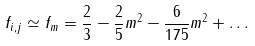Convert formula to latex. <formula><loc_0><loc_0><loc_500><loc_500>f _ { i , j } \simeq { f } _ { m } = \frac { 2 } { 3 } - \frac { 2 } { 5 } m ^ { 2 } - \frac { 6 } { 1 7 5 } m ^ { 2 } + \dots \,</formula> 